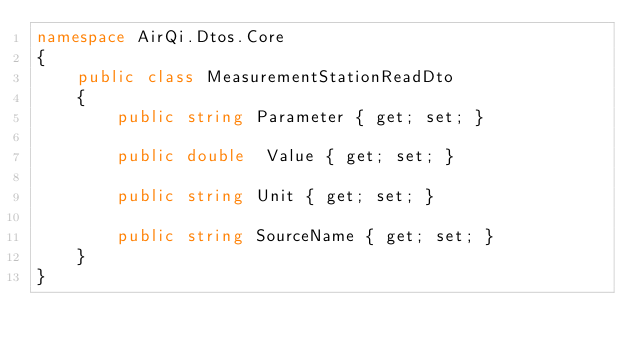Convert code to text. <code><loc_0><loc_0><loc_500><loc_500><_C#_>namespace AirQi.Dtos.Core
{
    public class MeasurementStationReadDto
    {        
        public string Parameter { get; set; }

        public double  Value { get; set; }

        public string Unit { get; set; }
                
        public string SourceName { get; set; }
    }
}</code> 